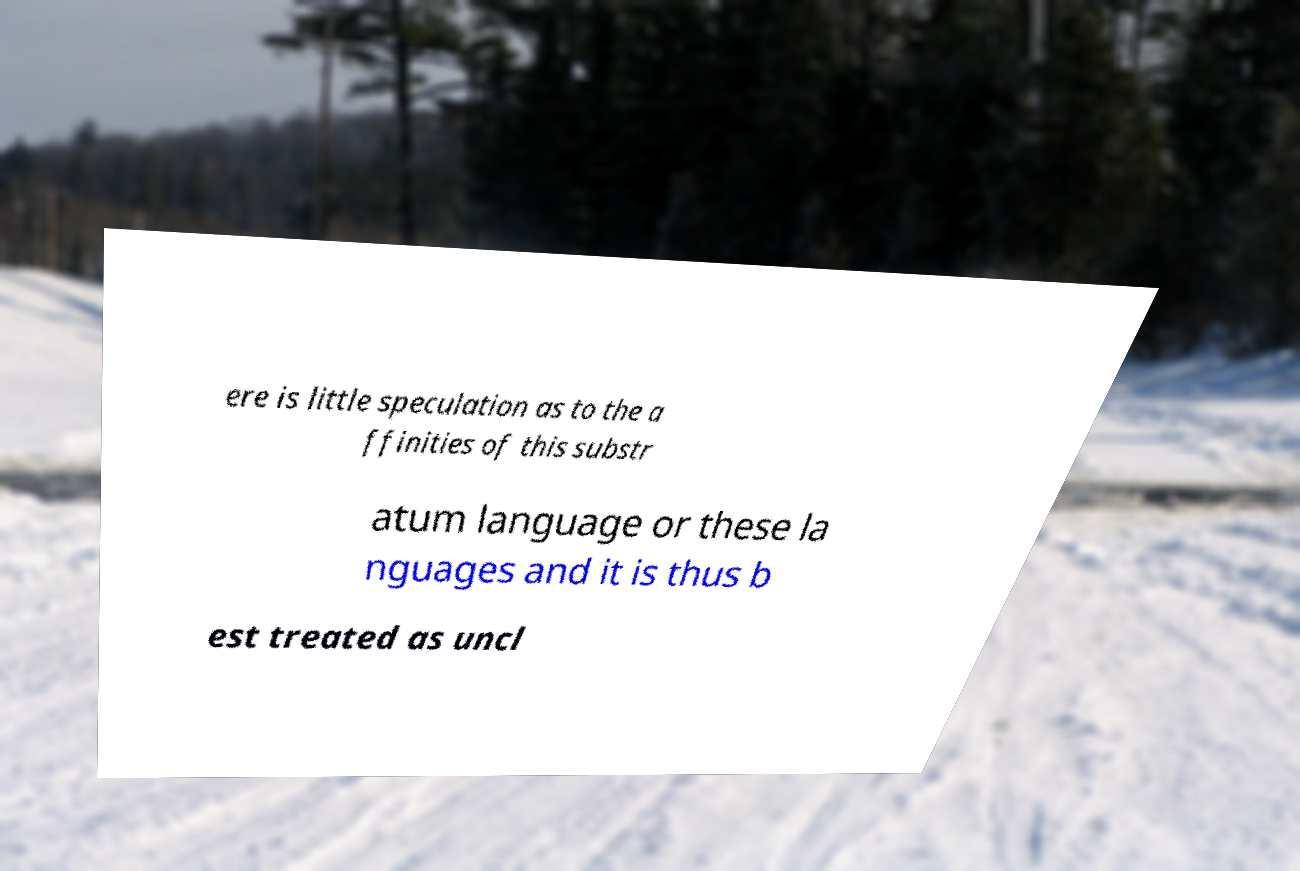Can you read and provide the text displayed in the image?This photo seems to have some interesting text. Can you extract and type it out for me? ere is little speculation as to the a ffinities of this substr atum language or these la nguages and it is thus b est treated as uncl 